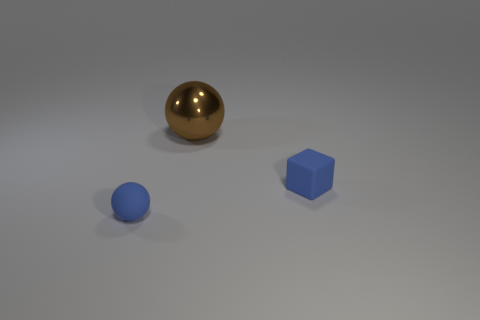Add 2 large metal spheres. How many objects exist? 5 Subtract all blue balls. How many balls are left? 1 Subtract 1 spheres. How many spheres are left? 1 Subtract all balls. How many objects are left? 1 Add 1 blue metallic spheres. How many blue metallic spheres exist? 1 Subtract 1 blue spheres. How many objects are left? 2 Subtract all green balls. Subtract all purple blocks. How many balls are left? 2 Subtract all cyan blocks. How many brown spheres are left? 1 Subtract all large shiny things. Subtract all big purple matte objects. How many objects are left? 2 Add 2 tiny cubes. How many tiny cubes are left? 3 